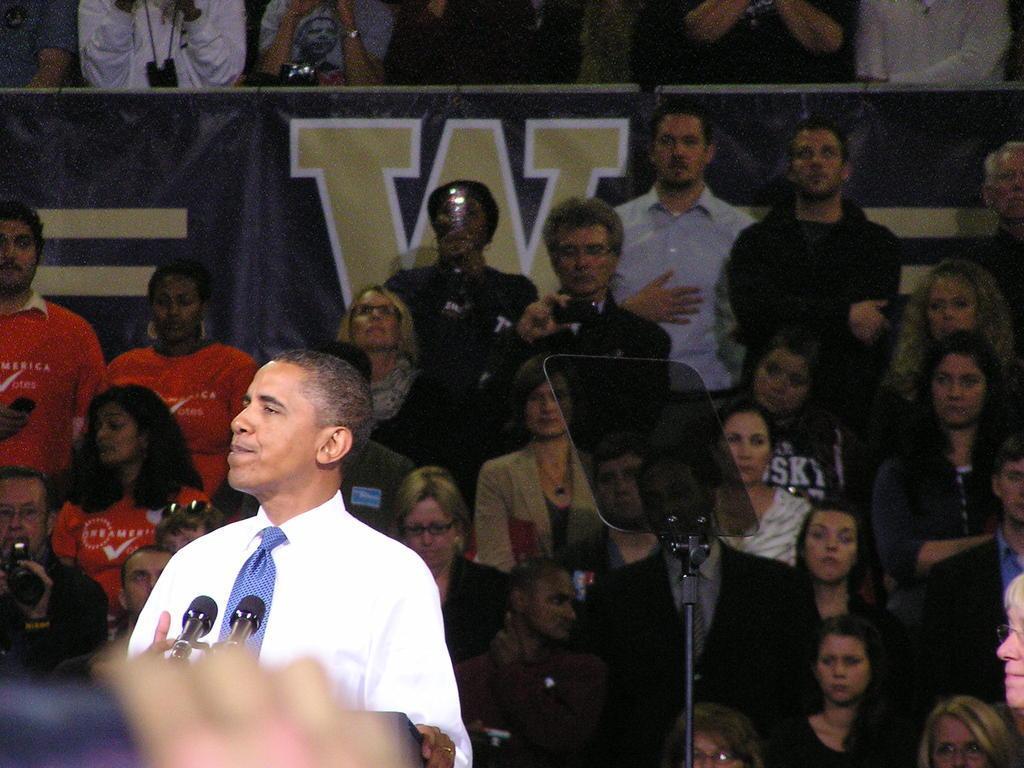Please provide a concise description of this image. In this image we can see a person standing near a speaker's stand with miles. On the backside we can see a stand, people sitting on the chairs and a board. 